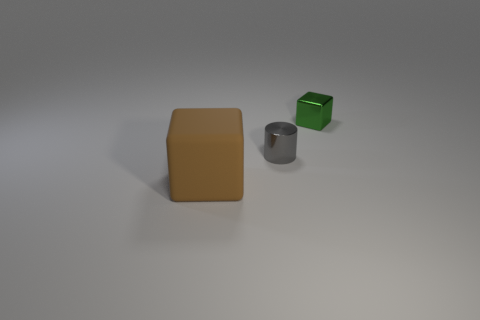How many gray objects are made of the same material as the green cube?
Your response must be concise. 1. There is a cube that is made of the same material as the cylinder; what color is it?
Make the answer very short. Green. The gray thing is what shape?
Offer a very short reply. Cylinder. There is a object that is in front of the tiny cylinder; what is it made of?
Give a very brief answer. Rubber. The other shiny thing that is the same size as the gray metallic thing is what shape?
Provide a succinct answer. Cube. There is a block behind the big block; what is its color?
Your answer should be compact. Green. There is a block that is behind the small gray metallic thing; are there any small gray cylinders in front of it?
Provide a succinct answer. Yes. How many things are things in front of the tiny green thing or tiny objects?
Provide a succinct answer. 3. Are there any other things that are the same size as the brown cube?
Your response must be concise. No. There is a cube left of the shiny thing left of the green object; what is it made of?
Offer a very short reply. Rubber. 